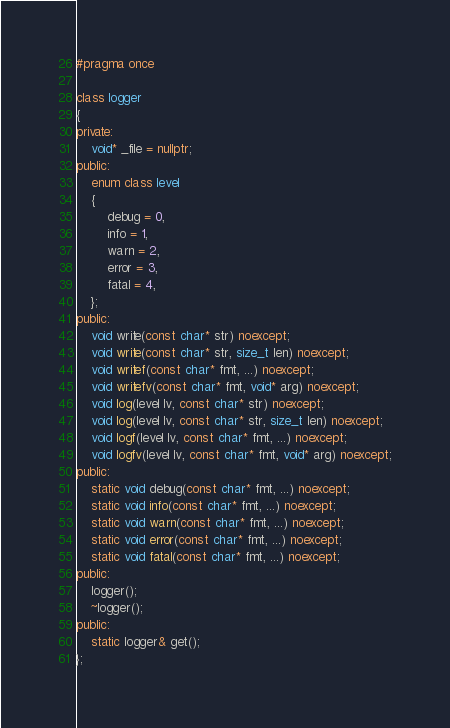<code> <loc_0><loc_0><loc_500><loc_500><_C++_>#pragma once

class logger
{
private:
    void* _file = nullptr;
public:
    enum class level
    {
        debug = 0,
        info = 1,
        warn = 2,
        error = 3,
        fatal = 4,
    };
public:
    void write(const char* str) noexcept;
    void write(const char* str, size_t len) noexcept;
    void writef(const char* fmt, ...) noexcept;
    void writefv(const char* fmt, void* arg) noexcept;
    void log(level lv, const char* str) noexcept;
    void log(level lv, const char* str, size_t len) noexcept;
    void logf(level lv, const char* fmt, ...) noexcept;
    void logfv(level lv, const char* fmt, void* arg) noexcept;
public:
    static void debug(const char* fmt, ...) noexcept;
    static void info(const char* fmt, ...) noexcept;
    static void warn(const char* fmt, ...) noexcept;
    static void error(const char* fmt, ...) noexcept;
    static void fatal(const char* fmt, ...) noexcept;
public:
    logger();
    ~logger();
public:
    static logger& get();
};
</code> 